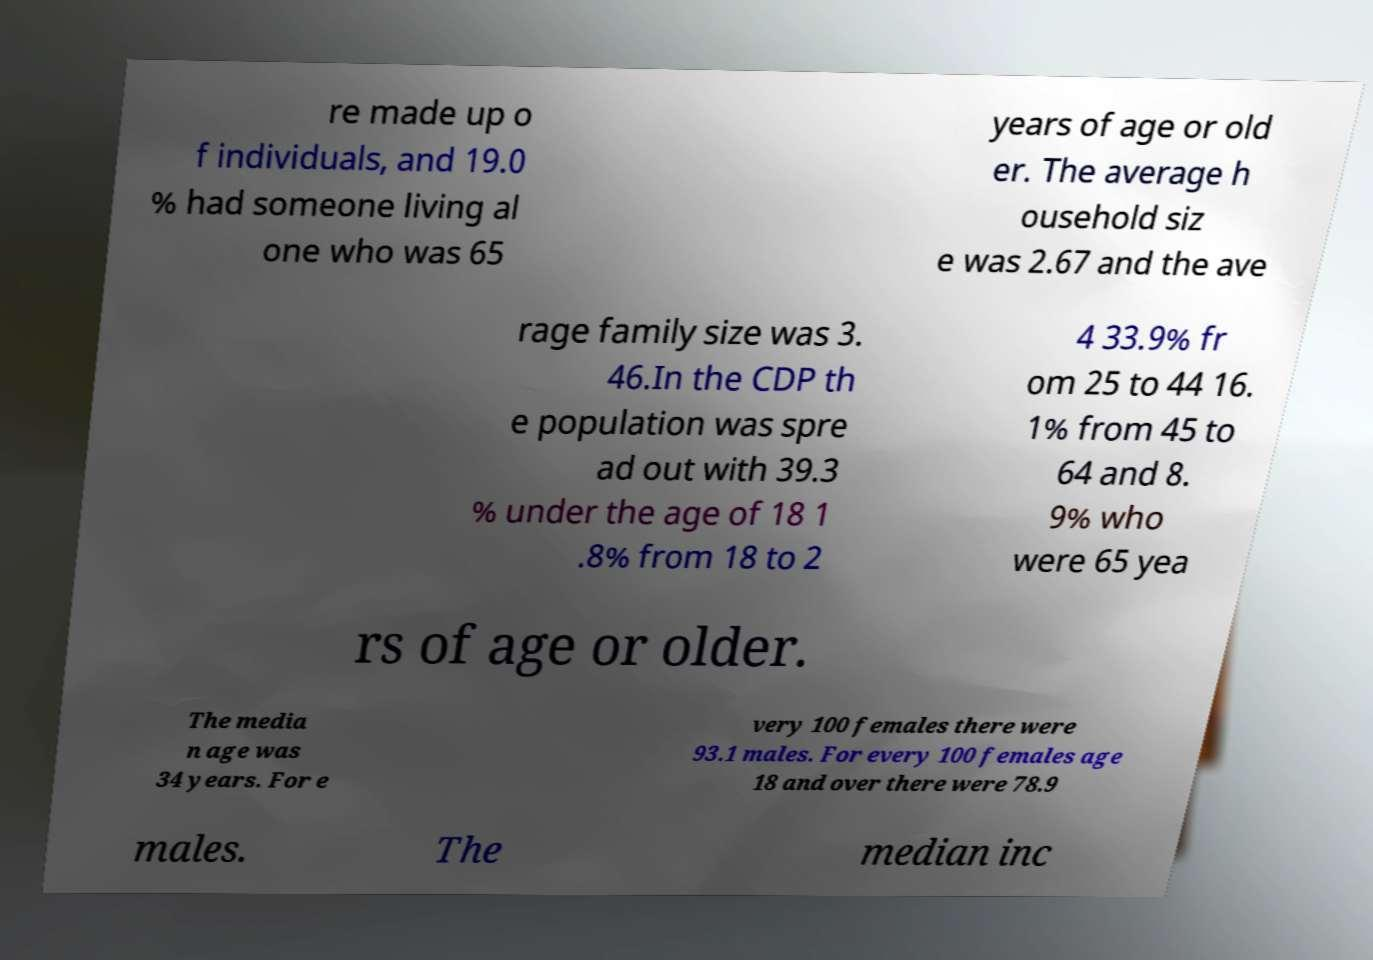I need the written content from this picture converted into text. Can you do that? re made up o f individuals, and 19.0 % had someone living al one who was 65 years of age or old er. The average h ousehold siz e was 2.67 and the ave rage family size was 3. 46.In the CDP th e population was spre ad out with 39.3 % under the age of 18 1 .8% from 18 to 2 4 33.9% fr om 25 to 44 16. 1% from 45 to 64 and 8. 9% who were 65 yea rs of age or older. The media n age was 34 years. For e very 100 females there were 93.1 males. For every 100 females age 18 and over there were 78.9 males. The median inc 